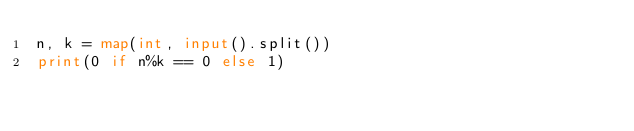Convert code to text. <code><loc_0><loc_0><loc_500><loc_500><_Python_>n, k = map(int, input().split())
print(0 if n%k == 0 else 1)</code> 